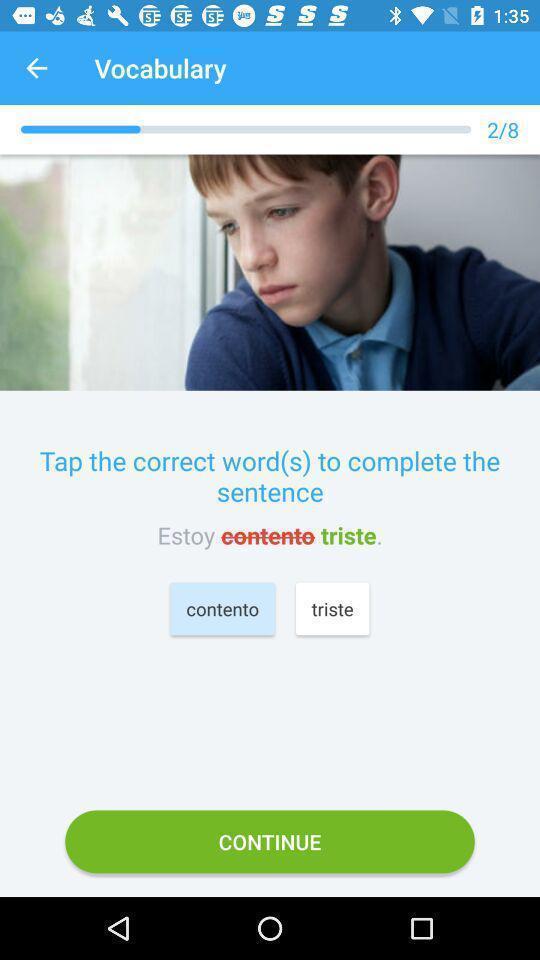Please provide a description for this image. Screen showing vocabulary words learning page. 